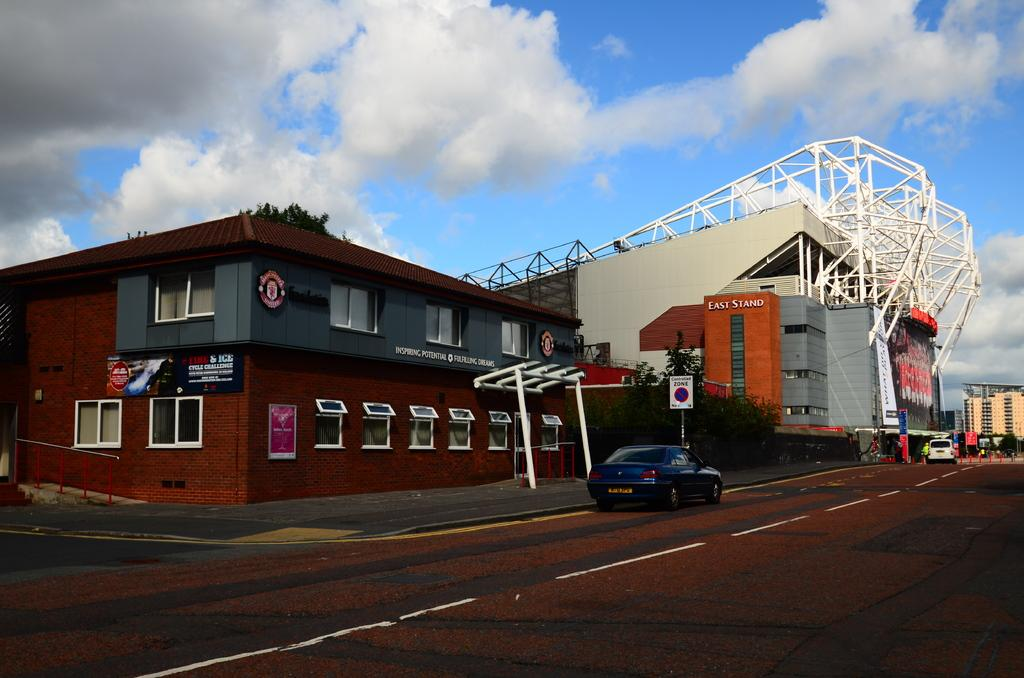What type of vehicles can be seen on the road in the image? There are cars on the road in the image. What structures are visible in the image? There are buildings in the image. What objects are present in the image that might be used for displaying information or advertisements? There are boards in the image. What architectural feature can be seen in the buildings? There are windows in the image. What is visible in the background of the image? The sky is visible in the background of the image. What type of weather can be inferred from the sky in the image? Clouds are present in the sky, suggesting that it might be a partly cloudy day. Can you see the mother holding a quince in the image? There is no mother or quince present in the image. How many fingers can be seen on the cars in the image? Cars do not have fingers, so this question cannot be answered. 